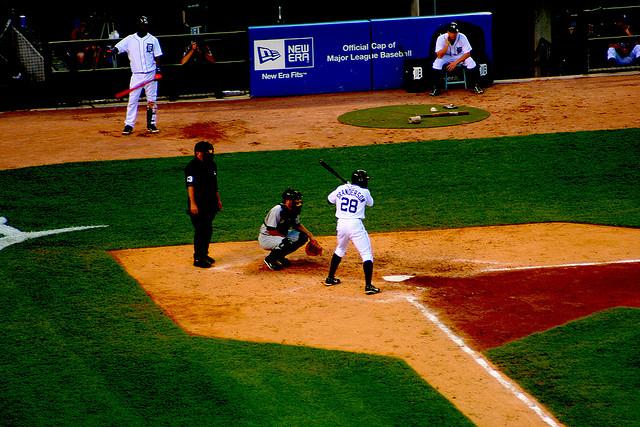What company is the ad for?
Be succinct. New era. What is the website on the board?
Quick response, please. New era. What color is the bat?
Keep it brief. Black. What number is at bat?
Write a very short answer. 28. 